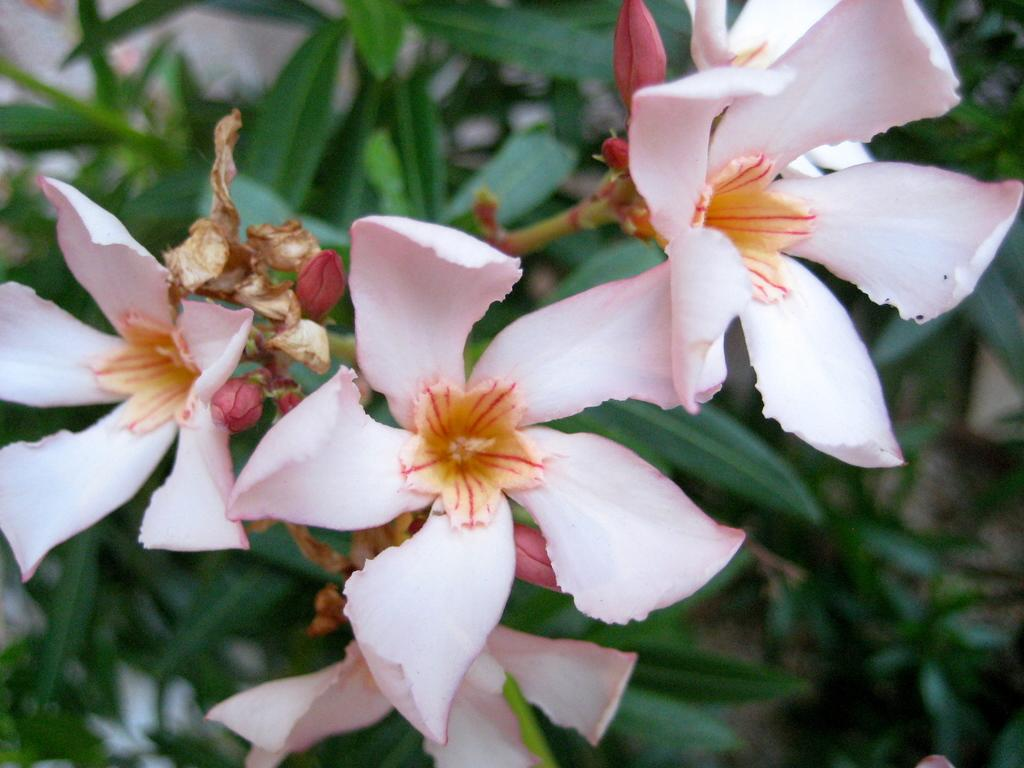What type of plants can be seen in the image? There are flowers and leaves in the image. Can you describe the appearance of the flowers? Unfortunately, the facts provided do not give specific details about the appearance of the flowers. What type of wall can be seen behind the flowers in the image? There is no wall visible in the image; it only features flowers and leaves. What type of wine is being poured over the flowers in the image? There is no wine present in the image; it only features flowers and leaves. 